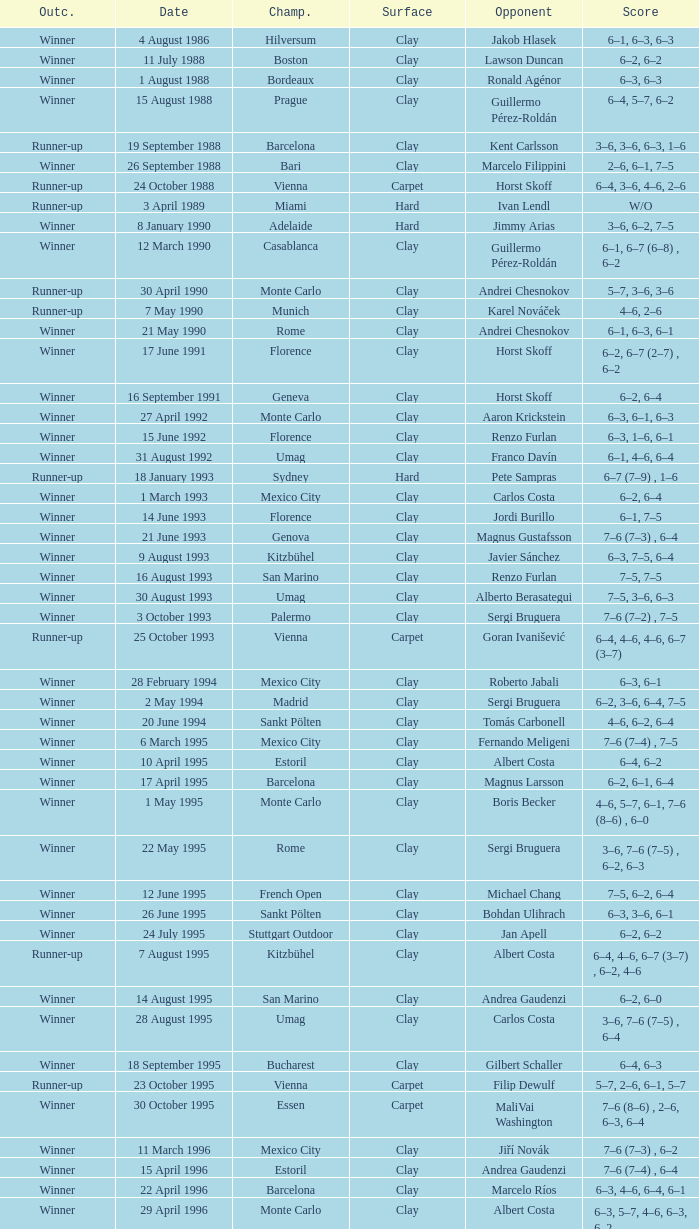What is the surface on 21 june 1993? Clay. 